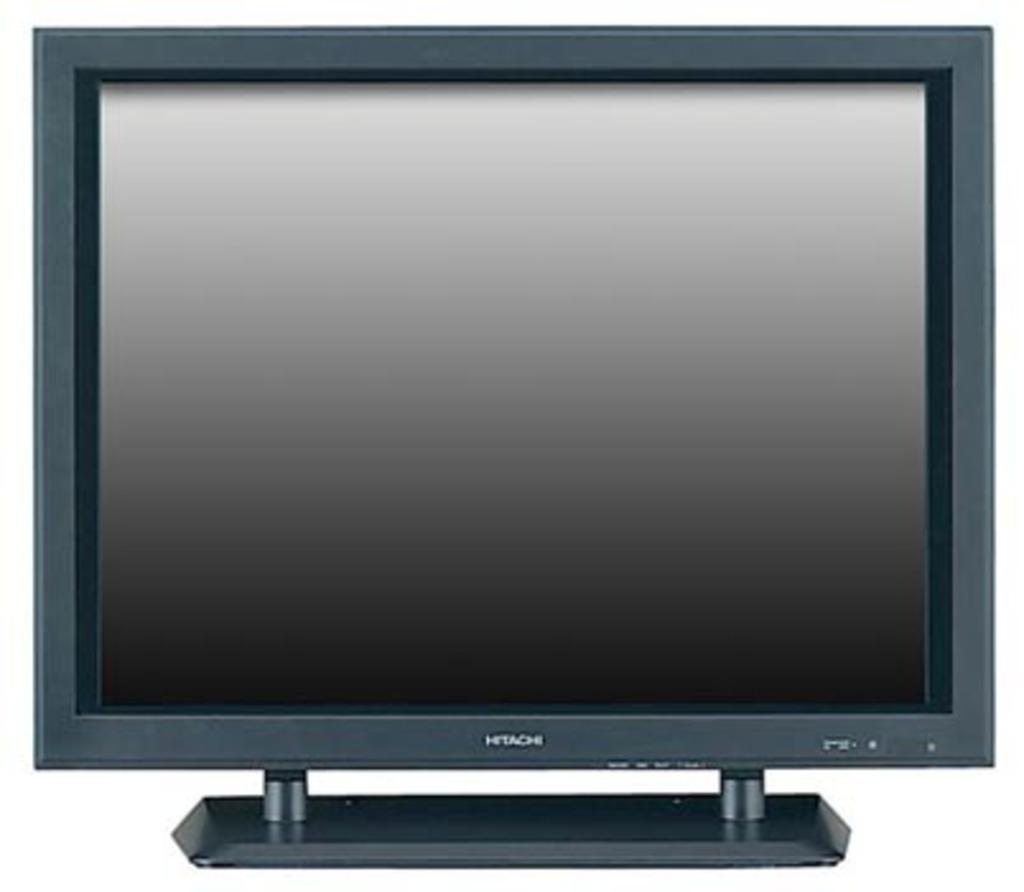<image>
Relay a brief, clear account of the picture shown. A Hitachi brand TV or computer monitor with a two legged stand on it. 